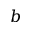<formula> <loc_0><loc_0><loc_500><loc_500>b</formula> 